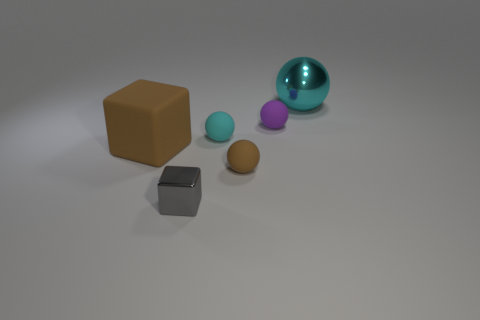How would you describe the composition of the objects in the image? The composition presents a scattered arrangement of shapes, with the largest object, the brown block, placed off-center to the left. This is balanced by the transparent blue sphere at the opposite end, creating a visual contrast in size and color. The smaller spheres are clustered towards the center, contributing to a sense of layering and depth in the image. 